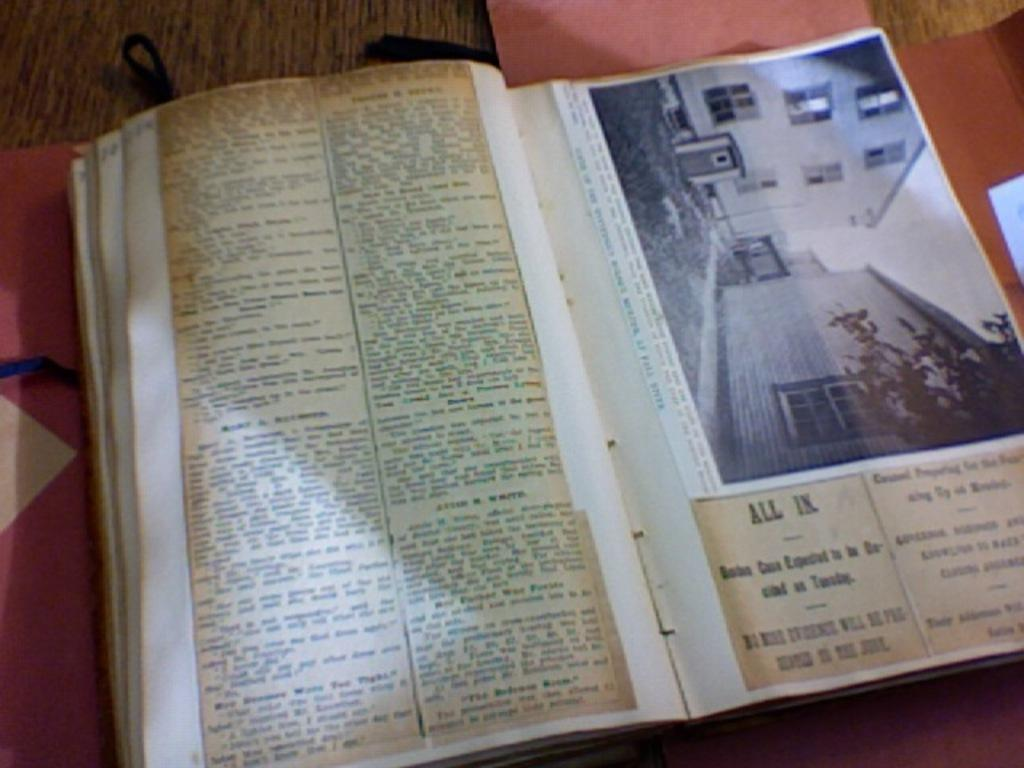<image>
Create a compact narrative representing the image presented. Open book on a page with the words "ALL IN." near the bottom. 